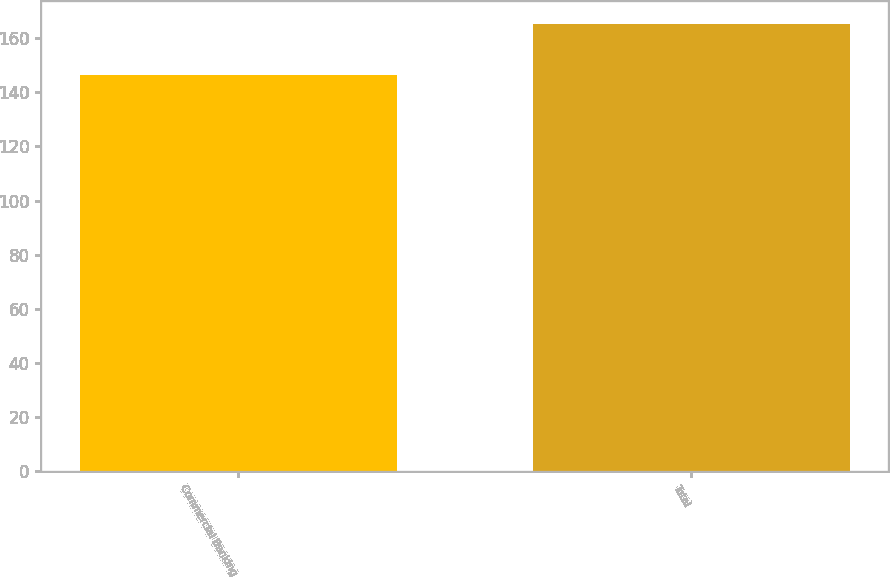Convert chart. <chart><loc_0><loc_0><loc_500><loc_500><bar_chart><fcel>Commercial Banking<fcel>Total<nl><fcel>146.3<fcel>165.3<nl></chart> 